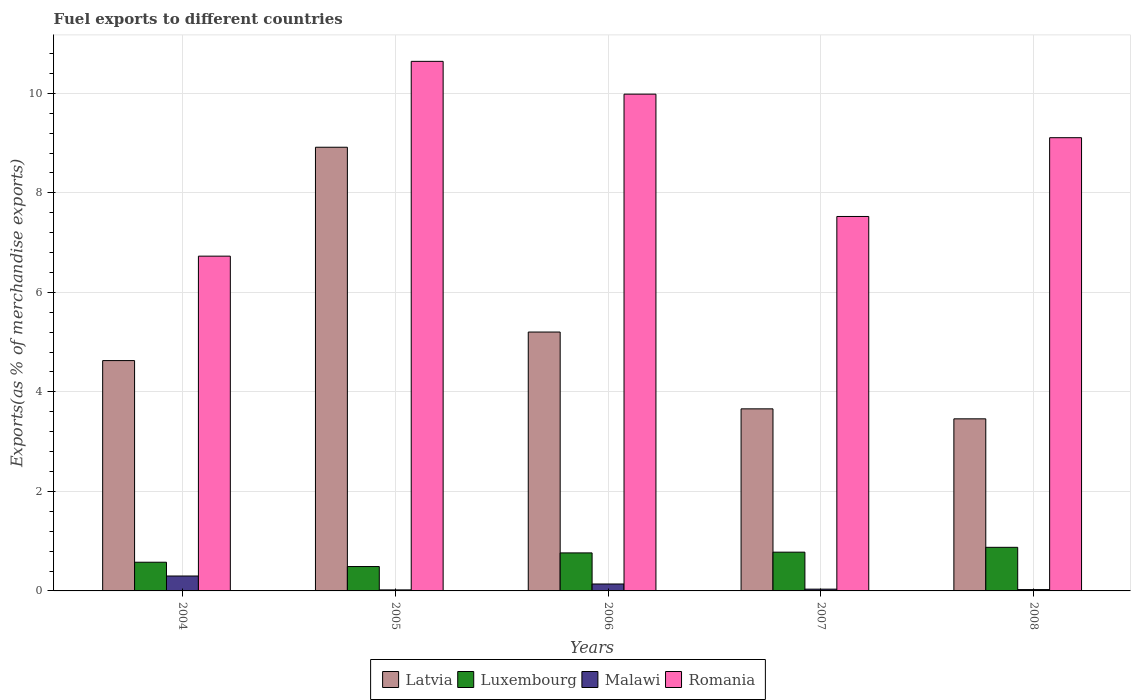How many groups of bars are there?
Offer a very short reply. 5. Are the number of bars on each tick of the X-axis equal?
Keep it short and to the point. Yes. How many bars are there on the 5th tick from the left?
Your answer should be very brief. 4. How many bars are there on the 5th tick from the right?
Provide a short and direct response. 4. What is the label of the 2nd group of bars from the left?
Make the answer very short. 2005. What is the percentage of exports to different countries in Malawi in 2007?
Make the answer very short. 0.04. Across all years, what is the maximum percentage of exports to different countries in Romania?
Ensure brevity in your answer.  10.64. Across all years, what is the minimum percentage of exports to different countries in Malawi?
Ensure brevity in your answer.  0.02. In which year was the percentage of exports to different countries in Malawi maximum?
Provide a short and direct response. 2004. In which year was the percentage of exports to different countries in Malawi minimum?
Offer a terse response. 2005. What is the total percentage of exports to different countries in Luxembourg in the graph?
Your answer should be very brief. 3.49. What is the difference between the percentage of exports to different countries in Latvia in 2004 and that in 2006?
Provide a short and direct response. -0.57. What is the difference between the percentage of exports to different countries in Malawi in 2007 and the percentage of exports to different countries in Romania in 2005?
Your response must be concise. -10.61. What is the average percentage of exports to different countries in Latvia per year?
Your answer should be very brief. 5.17. In the year 2004, what is the difference between the percentage of exports to different countries in Luxembourg and percentage of exports to different countries in Malawi?
Provide a short and direct response. 0.28. What is the ratio of the percentage of exports to different countries in Latvia in 2004 to that in 2007?
Keep it short and to the point. 1.27. Is the percentage of exports to different countries in Malawi in 2004 less than that in 2007?
Give a very brief answer. No. Is the difference between the percentage of exports to different countries in Luxembourg in 2004 and 2005 greater than the difference between the percentage of exports to different countries in Malawi in 2004 and 2005?
Your response must be concise. No. What is the difference between the highest and the second highest percentage of exports to different countries in Malawi?
Your response must be concise. 0.16. What is the difference between the highest and the lowest percentage of exports to different countries in Malawi?
Your response must be concise. 0.28. Is the sum of the percentage of exports to different countries in Luxembourg in 2005 and 2006 greater than the maximum percentage of exports to different countries in Romania across all years?
Provide a succinct answer. No. Is it the case that in every year, the sum of the percentage of exports to different countries in Romania and percentage of exports to different countries in Latvia is greater than the sum of percentage of exports to different countries in Luxembourg and percentage of exports to different countries in Malawi?
Your answer should be very brief. Yes. What does the 1st bar from the left in 2006 represents?
Provide a succinct answer. Latvia. What does the 4th bar from the right in 2006 represents?
Your answer should be very brief. Latvia. How many bars are there?
Provide a succinct answer. 20. How many years are there in the graph?
Your answer should be very brief. 5. Are the values on the major ticks of Y-axis written in scientific E-notation?
Offer a terse response. No. Does the graph contain grids?
Provide a short and direct response. Yes. How are the legend labels stacked?
Ensure brevity in your answer.  Horizontal. What is the title of the graph?
Your answer should be compact. Fuel exports to different countries. What is the label or title of the Y-axis?
Your answer should be very brief. Exports(as % of merchandise exports). What is the Exports(as % of merchandise exports) in Latvia in 2004?
Offer a very short reply. 4.63. What is the Exports(as % of merchandise exports) of Luxembourg in 2004?
Your answer should be compact. 0.58. What is the Exports(as % of merchandise exports) in Malawi in 2004?
Make the answer very short. 0.3. What is the Exports(as % of merchandise exports) of Romania in 2004?
Make the answer very short. 6.73. What is the Exports(as % of merchandise exports) in Latvia in 2005?
Your answer should be compact. 8.92. What is the Exports(as % of merchandise exports) of Luxembourg in 2005?
Your response must be concise. 0.49. What is the Exports(as % of merchandise exports) of Malawi in 2005?
Offer a terse response. 0.02. What is the Exports(as % of merchandise exports) of Romania in 2005?
Offer a terse response. 10.64. What is the Exports(as % of merchandise exports) of Latvia in 2006?
Offer a terse response. 5.2. What is the Exports(as % of merchandise exports) of Luxembourg in 2006?
Keep it short and to the point. 0.76. What is the Exports(as % of merchandise exports) of Malawi in 2006?
Provide a succinct answer. 0.14. What is the Exports(as % of merchandise exports) of Romania in 2006?
Your answer should be compact. 9.98. What is the Exports(as % of merchandise exports) in Latvia in 2007?
Make the answer very short. 3.66. What is the Exports(as % of merchandise exports) in Luxembourg in 2007?
Your response must be concise. 0.78. What is the Exports(as % of merchandise exports) in Malawi in 2007?
Give a very brief answer. 0.04. What is the Exports(as % of merchandise exports) of Romania in 2007?
Your response must be concise. 7.52. What is the Exports(as % of merchandise exports) of Latvia in 2008?
Your answer should be very brief. 3.46. What is the Exports(as % of merchandise exports) of Luxembourg in 2008?
Ensure brevity in your answer.  0.88. What is the Exports(as % of merchandise exports) in Malawi in 2008?
Provide a short and direct response. 0.03. What is the Exports(as % of merchandise exports) in Romania in 2008?
Provide a short and direct response. 9.11. Across all years, what is the maximum Exports(as % of merchandise exports) in Latvia?
Keep it short and to the point. 8.92. Across all years, what is the maximum Exports(as % of merchandise exports) of Luxembourg?
Make the answer very short. 0.88. Across all years, what is the maximum Exports(as % of merchandise exports) of Malawi?
Your answer should be compact. 0.3. Across all years, what is the maximum Exports(as % of merchandise exports) in Romania?
Your response must be concise. 10.64. Across all years, what is the minimum Exports(as % of merchandise exports) of Latvia?
Your answer should be compact. 3.46. Across all years, what is the minimum Exports(as % of merchandise exports) in Luxembourg?
Make the answer very short. 0.49. Across all years, what is the minimum Exports(as % of merchandise exports) in Malawi?
Make the answer very short. 0.02. Across all years, what is the minimum Exports(as % of merchandise exports) in Romania?
Ensure brevity in your answer.  6.73. What is the total Exports(as % of merchandise exports) in Latvia in the graph?
Ensure brevity in your answer.  25.86. What is the total Exports(as % of merchandise exports) in Luxembourg in the graph?
Offer a terse response. 3.49. What is the total Exports(as % of merchandise exports) in Malawi in the graph?
Ensure brevity in your answer.  0.52. What is the total Exports(as % of merchandise exports) in Romania in the graph?
Your answer should be very brief. 43.99. What is the difference between the Exports(as % of merchandise exports) of Latvia in 2004 and that in 2005?
Provide a short and direct response. -4.29. What is the difference between the Exports(as % of merchandise exports) in Luxembourg in 2004 and that in 2005?
Ensure brevity in your answer.  0.09. What is the difference between the Exports(as % of merchandise exports) in Malawi in 2004 and that in 2005?
Offer a terse response. 0.28. What is the difference between the Exports(as % of merchandise exports) in Romania in 2004 and that in 2005?
Your answer should be very brief. -3.91. What is the difference between the Exports(as % of merchandise exports) of Latvia in 2004 and that in 2006?
Offer a very short reply. -0.57. What is the difference between the Exports(as % of merchandise exports) of Luxembourg in 2004 and that in 2006?
Your response must be concise. -0.19. What is the difference between the Exports(as % of merchandise exports) in Malawi in 2004 and that in 2006?
Your answer should be very brief. 0.16. What is the difference between the Exports(as % of merchandise exports) of Romania in 2004 and that in 2006?
Provide a short and direct response. -3.26. What is the difference between the Exports(as % of merchandise exports) in Latvia in 2004 and that in 2007?
Offer a terse response. 0.97. What is the difference between the Exports(as % of merchandise exports) of Luxembourg in 2004 and that in 2007?
Ensure brevity in your answer.  -0.2. What is the difference between the Exports(as % of merchandise exports) of Malawi in 2004 and that in 2007?
Your response must be concise. 0.26. What is the difference between the Exports(as % of merchandise exports) in Romania in 2004 and that in 2007?
Your answer should be compact. -0.8. What is the difference between the Exports(as % of merchandise exports) of Latvia in 2004 and that in 2008?
Ensure brevity in your answer.  1.17. What is the difference between the Exports(as % of merchandise exports) of Luxembourg in 2004 and that in 2008?
Your answer should be compact. -0.3. What is the difference between the Exports(as % of merchandise exports) of Malawi in 2004 and that in 2008?
Provide a succinct answer. 0.27. What is the difference between the Exports(as % of merchandise exports) of Romania in 2004 and that in 2008?
Keep it short and to the point. -2.38. What is the difference between the Exports(as % of merchandise exports) of Latvia in 2005 and that in 2006?
Offer a terse response. 3.71. What is the difference between the Exports(as % of merchandise exports) of Luxembourg in 2005 and that in 2006?
Your answer should be very brief. -0.27. What is the difference between the Exports(as % of merchandise exports) in Malawi in 2005 and that in 2006?
Provide a short and direct response. -0.12. What is the difference between the Exports(as % of merchandise exports) in Romania in 2005 and that in 2006?
Make the answer very short. 0.66. What is the difference between the Exports(as % of merchandise exports) of Latvia in 2005 and that in 2007?
Make the answer very short. 5.26. What is the difference between the Exports(as % of merchandise exports) in Luxembourg in 2005 and that in 2007?
Offer a very short reply. -0.29. What is the difference between the Exports(as % of merchandise exports) of Malawi in 2005 and that in 2007?
Offer a terse response. -0.02. What is the difference between the Exports(as % of merchandise exports) of Romania in 2005 and that in 2007?
Your response must be concise. 3.12. What is the difference between the Exports(as % of merchandise exports) in Latvia in 2005 and that in 2008?
Your response must be concise. 5.46. What is the difference between the Exports(as % of merchandise exports) in Luxembourg in 2005 and that in 2008?
Keep it short and to the point. -0.39. What is the difference between the Exports(as % of merchandise exports) in Malawi in 2005 and that in 2008?
Give a very brief answer. -0.01. What is the difference between the Exports(as % of merchandise exports) of Romania in 2005 and that in 2008?
Offer a very short reply. 1.53. What is the difference between the Exports(as % of merchandise exports) in Latvia in 2006 and that in 2007?
Your response must be concise. 1.54. What is the difference between the Exports(as % of merchandise exports) of Luxembourg in 2006 and that in 2007?
Ensure brevity in your answer.  -0.01. What is the difference between the Exports(as % of merchandise exports) in Malawi in 2006 and that in 2007?
Offer a terse response. 0.1. What is the difference between the Exports(as % of merchandise exports) in Romania in 2006 and that in 2007?
Make the answer very short. 2.46. What is the difference between the Exports(as % of merchandise exports) in Latvia in 2006 and that in 2008?
Ensure brevity in your answer.  1.74. What is the difference between the Exports(as % of merchandise exports) of Luxembourg in 2006 and that in 2008?
Offer a terse response. -0.11. What is the difference between the Exports(as % of merchandise exports) of Malawi in 2006 and that in 2008?
Ensure brevity in your answer.  0.11. What is the difference between the Exports(as % of merchandise exports) in Romania in 2006 and that in 2008?
Give a very brief answer. 0.87. What is the difference between the Exports(as % of merchandise exports) in Latvia in 2007 and that in 2008?
Offer a terse response. 0.2. What is the difference between the Exports(as % of merchandise exports) of Luxembourg in 2007 and that in 2008?
Ensure brevity in your answer.  -0.1. What is the difference between the Exports(as % of merchandise exports) in Malawi in 2007 and that in 2008?
Give a very brief answer. 0.01. What is the difference between the Exports(as % of merchandise exports) in Romania in 2007 and that in 2008?
Your response must be concise. -1.58. What is the difference between the Exports(as % of merchandise exports) of Latvia in 2004 and the Exports(as % of merchandise exports) of Luxembourg in 2005?
Keep it short and to the point. 4.14. What is the difference between the Exports(as % of merchandise exports) of Latvia in 2004 and the Exports(as % of merchandise exports) of Malawi in 2005?
Offer a very short reply. 4.61. What is the difference between the Exports(as % of merchandise exports) in Latvia in 2004 and the Exports(as % of merchandise exports) in Romania in 2005?
Ensure brevity in your answer.  -6.01. What is the difference between the Exports(as % of merchandise exports) of Luxembourg in 2004 and the Exports(as % of merchandise exports) of Malawi in 2005?
Make the answer very short. 0.56. What is the difference between the Exports(as % of merchandise exports) in Luxembourg in 2004 and the Exports(as % of merchandise exports) in Romania in 2005?
Offer a terse response. -10.07. What is the difference between the Exports(as % of merchandise exports) of Malawi in 2004 and the Exports(as % of merchandise exports) of Romania in 2005?
Give a very brief answer. -10.34. What is the difference between the Exports(as % of merchandise exports) of Latvia in 2004 and the Exports(as % of merchandise exports) of Luxembourg in 2006?
Your answer should be compact. 3.86. What is the difference between the Exports(as % of merchandise exports) in Latvia in 2004 and the Exports(as % of merchandise exports) in Malawi in 2006?
Provide a succinct answer. 4.49. What is the difference between the Exports(as % of merchandise exports) of Latvia in 2004 and the Exports(as % of merchandise exports) of Romania in 2006?
Keep it short and to the point. -5.35. What is the difference between the Exports(as % of merchandise exports) of Luxembourg in 2004 and the Exports(as % of merchandise exports) of Malawi in 2006?
Your answer should be very brief. 0.44. What is the difference between the Exports(as % of merchandise exports) of Luxembourg in 2004 and the Exports(as % of merchandise exports) of Romania in 2006?
Make the answer very short. -9.41. What is the difference between the Exports(as % of merchandise exports) in Malawi in 2004 and the Exports(as % of merchandise exports) in Romania in 2006?
Give a very brief answer. -9.68. What is the difference between the Exports(as % of merchandise exports) of Latvia in 2004 and the Exports(as % of merchandise exports) of Luxembourg in 2007?
Your response must be concise. 3.85. What is the difference between the Exports(as % of merchandise exports) of Latvia in 2004 and the Exports(as % of merchandise exports) of Malawi in 2007?
Make the answer very short. 4.59. What is the difference between the Exports(as % of merchandise exports) of Latvia in 2004 and the Exports(as % of merchandise exports) of Romania in 2007?
Your response must be concise. -2.9. What is the difference between the Exports(as % of merchandise exports) of Luxembourg in 2004 and the Exports(as % of merchandise exports) of Malawi in 2007?
Provide a short and direct response. 0.54. What is the difference between the Exports(as % of merchandise exports) of Luxembourg in 2004 and the Exports(as % of merchandise exports) of Romania in 2007?
Make the answer very short. -6.95. What is the difference between the Exports(as % of merchandise exports) in Malawi in 2004 and the Exports(as % of merchandise exports) in Romania in 2007?
Give a very brief answer. -7.23. What is the difference between the Exports(as % of merchandise exports) of Latvia in 2004 and the Exports(as % of merchandise exports) of Luxembourg in 2008?
Your response must be concise. 3.75. What is the difference between the Exports(as % of merchandise exports) in Latvia in 2004 and the Exports(as % of merchandise exports) in Malawi in 2008?
Provide a succinct answer. 4.6. What is the difference between the Exports(as % of merchandise exports) of Latvia in 2004 and the Exports(as % of merchandise exports) of Romania in 2008?
Offer a terse response. -4.48. What is the difference between the Exports(as % of merchandise exports) in Luxembourg in 2004 and the Exports(as % of merchandise exports) in Malawi in 2008?
Your answer should be very brief. 0.55. What is the difference between the Exports(as % of merchandise exports) of Luxembourg in 2004 and the Exports(as % of merchandise exports) of Romania in 2008?
Provide a short and direct response. -8.53. What is the difference between the Exports(as % of merchandise exports) of Malawi in 2004 and the Exports(as % of merchandise exports) of Romania in 2008?
Your response must be concise. -8.81. What is the difference between the Exports(as % of merchandise exports) of Latvia in 2005 and the Exports(as % of merchandise exports) of Luxembourg in 2006?
Provide a succinct answer. 8.15. What is the difference between the Exports(as % of merchandise exports) in Latvia in 2005 and the Exports(as % of merchandise exports) in Malawi in 2006?
Ensure brevity in your answer.  8.78. What is the difference between the Exports(as % of merchandise exports) in Latvia in 2005 and the Exports(as % of merchandise exports) in Romania in 2006?
Give a very brief answer. -1.07. What is the difference between the Exports(as % of merchandise exports) in Luxembourg in 2005 and the Exports(as % of merchandise exports) in Malawi in 2006?
Your answer should be compact. 0.35. What is the difference between the Exports(as % of merchandise exports) in Luxembourg in 2005 and the Exports(as % of merchandise exports) in Romania in 2006?
Your answer should be compact. -9.49. What is the difference between the Exports(as % of merchandise exports) of Malawi in 2005 and the Exports(as % of merchandise exports) of Romania in 2006?
Your answer should be very brief. -9.96. What is the difference between the Exports(as % of merchandise exports) of Latvia in 2005 and the Exports(as % of merchandise exports) of Luxembourg in 2007?
Offer a very short reply. 8.14. What is the difference between the Exports(as % of merchandise exports) of Latvia in 2005 and the Exports(as % of merchandise exports) of Malawi in 2007?
Give a very brief answer. 8.88. What is the difference between the Exports(as % of merchandise exports) in Latvia in 2005 and the Exports(as % of merchandise exports) in Romania in 2007?
Offer a very short reply. 1.39. What is the difference between the Exports(as % of merchandise exports) in Luxembourg in 2005 and the Exports(as % of merchandise exports) in Malawi in 2007?
Provide a short and direct response. 0.45. What is the difference between the Exports(as % of merchandise exports) in Luxembourg in 2005 and the Exports(as % of merchandise exports) in Romania in 2007?
Offer a terse response. -7.03. What is the difference between the Exports(as % of merchandise exports) in Malawi in 2005 and the Exports(as % of merchandise exports) in Romania in 2007?
Give a very brief answer. -7.5. What is the difference between the Exports(as % of merchandise exports) of Latvia in 2005 and the Exports(as % of merchandise exports) of Luxembourg in 2008?
Make the answer very short. 8.04. What is the difference between the Exports(as % of merchandise exports) of Latvia in 2005 and the Exports(as % of merchandise exports) of Malawi in 2008?
Make the answer very short. 8.89. What is the difference between the Exports(as % of merchandise exports) in Latvia in 2005 and the Exports(as % of merchandise exports) in Romania in 2008?
Make the answer very short. -0.19. What is the difference between the Exports(as % of merchandise exports) of Luxembourg in 2005 and the Exports(as % of merchandise exports) of Malawi in 2008?
Your answer should be very brief. 0.46. What is the difference between the Exports(as % of merchandise exports) of Luxembourg in 2005 and the Exports(as % of merchandise exports) of Romania in 2008?
Provide a succinct answer. -8.62. What is the difference between the Exports(as % of merchandise exports) in Malawi in 2005 and the Exports(as % of merchandise exports) in Romania in 2008?
Your answer should be compact. -9.09. What is the difference between the Exports(as % of merchandise exports) in Latvia in 2006 and the Exports(as % of merchandise exports) in Luxembourg in 2007?
Your answer should be very brief. 4.42. What is the difference between the Exports(as % of merchandise exports) in Latvia in 2006 and the Exports(as % of merchandise exports) in Malawi in 2007?
Keep it short and to the point. 5.17. What is the difference between the Exports(as % of merchandise exports) of Latvia in 2006 and the Exports(as % of merchandise exports) of Romania in 2007?
Provide a succinct answer. -2.32. What is the difference between the Exports(as % of merchandise exports) in Luxembourg in 2006 and the Exports(as % of merchandise exports) in Malawi in 2007?
Provide a short and direct response. 0.73. What is the difference between the Exports(as % of merchandise exports) of Luxembourg in 2006 and the Exports(as % of merchandise exports) of Romania in 2007?
Your answer should be compact. -6.76. What is the difference between the Exports(as % of merchandise exports) of Malawi in 2006 and the Exports(as % of merchandise exports) of Romania in 2007?
Your answer should be very brief. -7.39. What is the difference between the Exports(as % of merchandise exports) in Latvia in 2006 and the Exports(as % of merchandise exports) in Luxembourg in 2008?
Your answer should be very brief. 4.33. What is the difference between the Exports(as % of merchandise exports) in Latvia in 2006 and the Exports(as % of merchandise exports) in Malawi in 2008?
Your answer should be very brief. 5.18. What is the difference between the Exports(as % of merchandise exports) in Latvia in 2006 and the Exports(as % of merchandise exports) in Romania in 2008?
Keep it short and to the point. -3.91. What is the difference between the Exports(as % of merchandise exports) of Luxembourg in 2006 and the Exports(as % of merchandise exports) of Malawi in 2008?
Offer a very short reply. 0.74. What is the difference between the Exports(as % of merchandise exports) of Luxembourg in 2006 and the Exports(as % of merchandise exports) of Romania in 2008?
Offer a very short reply. -8.34. What is the difference between the Exports(as % of merchandise exports) in Malawi in 2006 and the Exports(as % of merchandise exports) in Romania in 2008?
Provide a short and direct response. -8.97. What is the difference between the Exports(as % of merchandise exports) of Latvia in 2007 and the Exports(as % of merchandise exports) of Luxembourg in 2008?
Ensure brevity in your answer.  2.78. What is the difference between the Exports(as % of merchandise exports) in Latvia in 2007 and the Exports(as % of merchandise exports) in Malawi in 2008?
Offer a very short reply. 3.63. What is the difference between the Exports(as % of merchandise exports) of Latvia in 2007 and the Exports(as % of merchandise exports) of Romania in 2008?
Provide a short and direct response. -5.45. What is the difference between the Exports(as % of merchandise exports) in Luxembourg in 2007 and the Exports(as % of merchandise exports) in Malawi in 2008?
Provide a succinct answer. 0.75. What is the difference between the Exports(as % of merchandise exports) in Luxembourg in 2007 and the Exports(as % of merchandise exports) in Romania in 2008?
Offer a very short reply. -8.33. What is the difference between the Exports(as % of merchandise exports) of Malawi in 2007 and the Exports(as % of merchandise exports) of Romania in 2008?
Give a very brief answer. -9.07. What is the average Exports(as % of merchandise exports) in Latvia per year?
Offer a very short reply. 5.17. What is the average Exports(as % of merchandise exports) in Luxembourg per year?
Provide a succinct answer. 0.7. What is the average Exports(as % of merchandise exports) of Malawi per year?
Ensure brevity in your answer.  0.1. What is the average Exports(as % of merchandise exports) in Romania per year?
Make the answer very short. 8.8. In the year 2004, what is the difference between the Exports(as % of merchandise exports) of Latvia and Exports(as % of merchandise exports) of Luxembourg?
Offer a terse response. 4.05. In the year 2004, what is the difference between the Exports(as % of merchandise exports) in Latvia and Exports(as % of merchandise exports) in Malawi?
Offer a very short reply. 4.33. In the year 2004, what is the difference between the Exports(as % of merchandise exports) of Latvia and Exports(as % of merchandise exports) of Romania?
Ensure brevity in your answer.  -2.1. In the year 2004, what is the difference between the Exports(as % of merchandise exports) of Luxembourg and Exports(as % of merchandise exports) of Malawi?
Ensure brevity in your answer.  0.28. In the year 2004, what is the difference between the Exports(as % of merchandise exports) in Luxembourg and Exports(as % of merchandise exports) in Romania?
Provide a succinct answer. -6.15. In the year 2004, what is the difference between the Exports(as % of merchandise exports) of Malawi and Exports(as % of merchandise exports) of Romania?
Make the answer very short. -6.43. In the year 2005, what is the difference between the Exports(as % of merchandise exports) in Latvia and Exports(as % of merchandise exports) in Luxembourg?
Keep it short and to the point. 8.43. In the year 2005, what is the difference between the Exports(as % of merchandise exports) in Latvia and Exports(as % of merchandise exports) in Malawi?
Your response must be concise. 8.9. In the year 2005, what is the difference between the Exports(as % of merchandise exports) in Latvia and Exports(as % of merchandise exports) in Romania?
Keep it short and to the point. -1.73. In the year 2005, what is the difference between the Exports(as % of merchandise exports) of Luxembourg and Exports(as % of merchandise exports) of Malawi?
Your answer should be very brief. 0.47. In the year 2005, what is the difference between the Exports(as % of merchandise exports) in Luxembourg and Exports(as % of merchandise exports) in Romania?
Offer a very short reply. -10.15. In the year 2005, what is the difference between the Exports(as % of merchandise exports) in Malawi and Exports(as % of merchandise exports) in Romania?
Give a very brief answer. -10.62. In the year 2006, what is the difference between the Exports(as % of merchandise exports) in Latvia and Exports(as % of merchandise exports) in Luxembourg?
Your answer should be compact. 4.44. In the year 2006, what is the difference between the Exports(as % of merchandise exports) in Latvia and Exports(as % of merchandise exports) in Malawi?
Make the answer very short. 5.06. In the year 2006, what is the difference between the Exports(as % of merchandise exports) of Latvia and Exports(as % of merchandise exports) of Romania?
Offer a very short reply. -4.78. In the year 2006, what is the difference between the Exports(as % of merchandise exports) of Luxembourg and Exports(as % of merchandise exports) of Malawi?
Your answer should be very brief. 0.62. In the year 2006, what is the difference between the Exports(as % of merchandise exports) of Luxembourg and Exports(as % of merchandise exports) of Romania?
Your response must be concise. -9.22. In the year 2006, what is the difference between the Exports(as % of merchandise exports) of Malawi and Exports(as % of merchandise exports) of Romania?
Give a very brief answer. -9.84. In the year 2007, what is the difference between the Exports(as % of merchandise exports) in Latvia and Exports(as % of merchandise exports) in Luxembourg?
Offer a terse response. 2.88. In the year 2007, what is the difference between the Exports(as % of merchandise exports) of Latvia and Exports(as % of merchandise exports) of Malawi?
Provide a succinct answer. 3.62. In the year 2007, what is the difference between the Exports(as % of merchandise exports) in Latvia and Exports(as % of merchandise exports) in Romania?
Offer a very short reply. -3.87. In the year 2007, what is the difference between the Exports(as % of merchandise exports) in Luxembourg and Exports(as % of merchandise exports) in Malawi?
Offer a very short reply. 0.74. In the year 2007, what is the difference between the Exports(as % of merchandise exports) of Luxembourg and Exports(as % of merchandise exports) of Romania?
Make the answer very short. -6.75. In the year 2007, what is the difference between the Exports(as % of merchandise exports) of Malawi and Exports(as % of merchandise exports) of Romania?
Ensure brevity in your answer.  -7.49. In the year 2008, what is the difference between the Exports(as % of merchandise exports) of Latvia and Exports(as % of merchandise exports) of Luxembourg?
Make the answer very short. 2.58. In the year 2008, what is the difference between the Exports(as % of merchandise exports) in Latvia and Exports(as % of merchandise exports) in Malawi?
Provide a succinct answer. 3.43. In the year 2008, what is the difference between the Exports(as % of merchandise exports) of Latvia and Exports(as % of merchandise exports) of Romania?
Your answer should be very brief. -5.65. In the year 2008, what is the difference between the Exports(as % of merchandise exports) in Luxembourg and Exports(as % of merchandise exports) in Malawi?
Make the answer very short. 0.85. In the year 2008, what is the difference between the Exports(as % of merchandise exports) of Luxembourg and Exports(as % of merchandise exports) of Romania?
Ensure brevity in your answer.  -8.23. In the year 2008, what is the difference between the Exports(as % of merchandise exports) of Malawi and Exports(as % of merchandise exports) of Romania?
Offer a terse response. -9.08. What is the ratio of the Exports(as % of merchandise exports) of Latvia in 2004 to that in 2005?
Ensure brevity in your answer.  0.52. What is the ratio of the Exports(as % of merchandise exports) in Luxembourg in 2004 to that in 2005?
Your response must be concise. 1.18. What is the ratio of the Exports(as % of merchandise exports) of Malawi in 2004 to that in 2005?
Ensure brevity in your answer.  14.64. What is the ratio of the Exports(as % of merchandise exports) in Romania in 2004 to that in 2005?
Keep it short and to the point. 0.63. What is the ratio of the Exports(as % of merchandise exports) in Latvia in 2004 to that in 2006?
Make the answer very short. 0.89. What is the ratio of the Exports(as % of merchandise exports) in Luxembourg in 2004 to that in 2006?
Provide a short and direct response. 0.75. What is the ratio of the Exports(as % of merchandise exports) of Malawi in 2004 to that in 2006?
Offer a very short reply. 2.15. What is the ratio of the Exports(as % of merchandise exports) in Romania in 2004 to that in 2006?
Your answer should be very brief. 0.67. What is the ratio of the Exports(as % of merchandise exports) in Latvia in 2004 to that in 2007?
Your response must be concise. 1.27. What is the ratio of the Exports(as % of merchandise exports) in Luxembourg in 2004 to that in 2007?
Provide a succinct answer. 0.74. What is the ratio of the Exports(as % of merchandise exports) in Malawi in 2004 to that in 2007?
Offer a very short reply. 8.37. What is the ratio of the Exports(as % of merchandise exports) of Romania in 2004 to that in 2007?
Provide a short and direct response. 0.89. What is the ratio of the Exports(as % of merchandise exports) in Latvia in 2004 to that in 2008?
Provide a succinct answer. 1.34. What is the ratio of the Exports(as % of merchandise exports) of Luxembourg in 2004 to that in 2008?
Provide a short and direct response. 0.66. What is the ratio of the Exports(as % of merchandise exports) of Malawi in 2004 to that in 2008?
Keep it short and to the point. 11.11. What is the ratio of the Exports(as % of merchandise exports) in Romania in 2004 to that in 2008?
Ensure brevity in your answer.  0.74. What is the ratio of the Exports(as % of merchandise exports) of Latvia in 2005 to that in 2006?
Your response must be concise. 1.71. What is the ratio of the Exports(as % of merchandise exports) in Luxembourg in 2005 to that in 2006?
Your answer should be compact. 0.64. What is the ratio of the Exports(as % of merchandise exports) in Malawi in 2005 to that in 2006?
Offer a very short reply. 0.15. What is the ratio of the Exports(as % of merchandise exports) of Romania in 2005 to that in 2006?
Provide a succinct answer. 1.07. What is the ratio of the Exports(as % of merchandise exports) in Latvia in 2005 to that in 2007?
Your answer should be very brief. 2.44. What is the ratio of the Exports(as % of merchandise exports) of Luxembourg in 2005 to that in 2007?
Your answer should be compact. 0.63. What is the ratio of the Exports(as % of merchandise exports) in Malawi in 2005 to that in 2007?
Give a very brief answer. 0.57. What is the ratio of the Exports(as % of merchandise exports) in Romania in 2005 to that in 2007?
Provide a short and direct response. 1.41. What is the ratio of the Exports(as % of merchandise exports) in Latvia in 2005 to that in 2008?
Provide a short and direct response. 2.58. What is the ratio of the Exports(as % of merchandise exports) in Luxembourg in 2005 to that in 2008?
Keep it short and to the point. 0.56. What is the ratio of the Exports(as % of merchandise exports) of Malawi in 2005 to that in 2008?
Give a very brief answer. 0.76. What is the ratio of the Exports(as % of merchandise exports) of Romania in 2005 to that in 2008?
Ensure brevity in your answer.  1.17. What is the ratio of the Exports(as % of merchandise exports) in Latvia in 2006 to that in 2007?
Your response must be concise. 1.42. What is the ratio of the Exports(as % of merchandise exports) of Luxembourg in 2006 to that in 2007?
Offer a terse response. 0.98. What is the ratio of the Exports(as % of merchandise exports) of Malawi in 2006 to that in 2007?
Give a very brief answer. 3.9. What is the ratio of the Exports(as % of merchandise exports) in Romania in 2006 to that in 2007?
Your answer should be compact. 1.33. What is the ratio of the Exports(as % of merchandise exports) of Latvia in 2006 to that in 2008?
Give a very brief answer. 1.5. What is the ratio of the Exports(as % of merchandise exports) in Luxembourg in 2006 to that in 2008?
Give a very brief answer. 0.87. What is the ratio of the Exports(as % of merchandise exports) in Malawi in 2006 to that in 2008?
Your answer should be compact. 5.17. What is the ratio of the Exports(as % of merchandise exports) of Romania in 2006 to that in 2008?
Ensure brevity in your answer.  1.1. What is the ratio of the Exports(as % of merchandise exports) in Latvia in 2007 to that in 2008?
Keep it short and to the point. 1.06. What is the ratio of the Exports(as % of merchandise exports) in Luxembourg in 2007 to that in 2008?
Provide a succinct answer. 0.89. What is the ratio of the Exports(as % of merchandise exports) of Malawi in 2007 to that in 2008?
Provide a succinct answer. 1.33. What is the ratio of the Exports(as % of merchandise exports) in Romania in 2007 to that in 2008?
Ensure brevity in your answer.  0.83. What is the difference between the highest and the second highest Exports(as % of merchandise exports) of Latvia?
Offer a terse response. 3.71. What is the difference between the highest and the second highest Exports(as % of merchandise exports) in Luxembourg?
Offer a terse response. 0.1. What is the difference between the highest and the second highest Exports(as % of merchandise exports) in Malawi?
Give a very brief answer. 0.16. What is the difference between the highest and the second highest Exports(as % of merchandise exports) of Romania?
Offer a terse response. 0.66. What is the difference between the highest and the lowest Exports(as % of merchandise exports) of Latvia?
Ensure brevity in your answer.  5.46. What is the difference between the highest and the lowest Exports(as % of merchandise exports) of Luxembourg?
Your answer should be compact. 0.39. What is the difference between the highest and the lowest Exports(as % of merchandise exports) in Malawi?
Offer a very short reply. 0.28. What is the difference between the highest and the lowest Exports(as % of merchandise exports) of Romania?
Offer a very short reply. 3.91. 